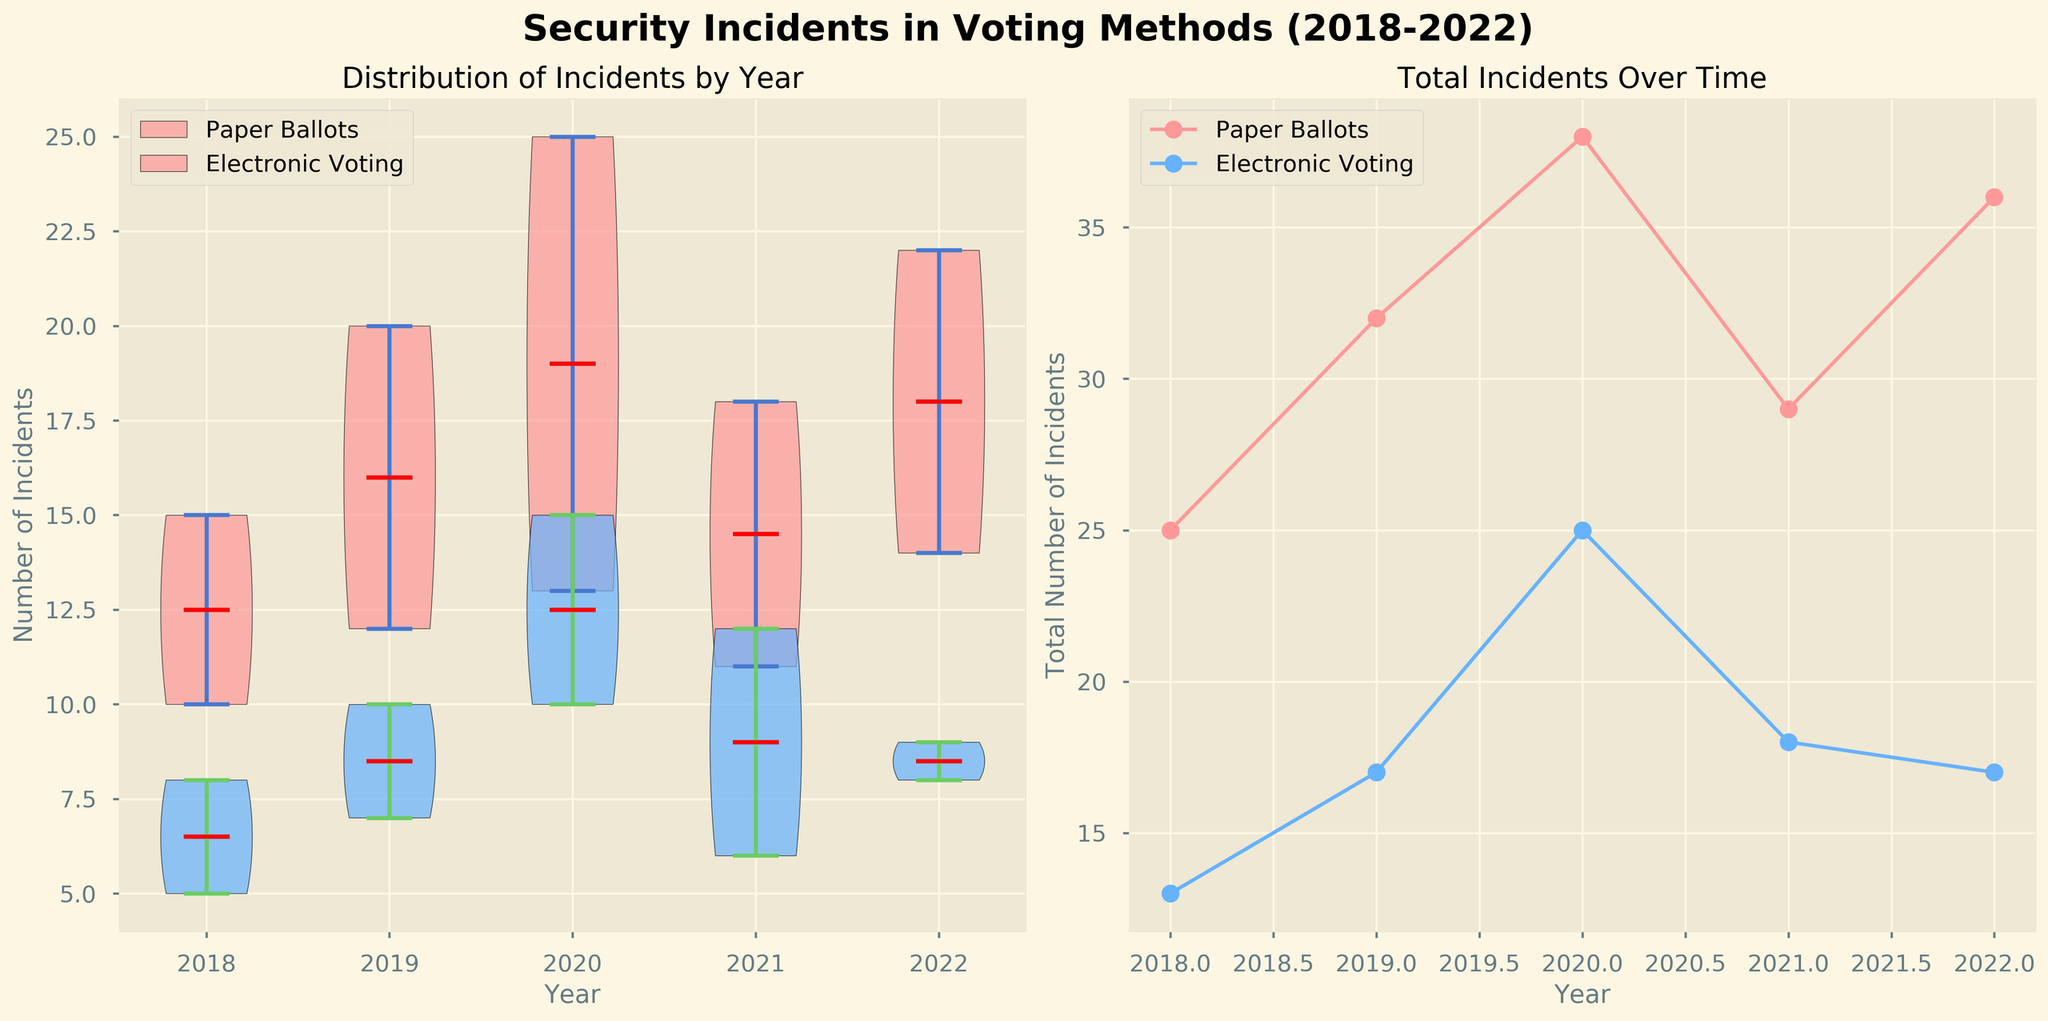What's the title of the figure? The title is usually displayed at the top of the figure, and it states the main topic or focus of the visualized data. In this case, it's clearly labeled at the top of the figure.
Answer: Security Incidents in Voting Methods (2018-2022) What are the unique voting methods shown in the figure? The unique voting methods are often shown in the legends or labels in a plot. Here, we see two distinct methods labeled in the legend and represented by different colors in the plots.
Answer: Paper Ballots and Electronic Voting Which year had the highest total number of security incidents across all methods? To find the highest total, sum the incidents for each year in both plots, then compare these sums. The year 2020 has the highest total when looking at both the line and violin plots.
Answer: 2020 What color represents 'Electronic Voting' in the plots? The colors associated with different methods can usually be deduced from the legend or the distinct colors used in the plot elements. The color for 'Electronic Voting' in this figure is visible in both the line and violin plots.
Answer: Blue Which method had a higher median number of incidents in 2020? The median is shown as a red line in the violin plot. Comparing the medians of 'Paper Ballots' and 'Electronic Voting' in 2020 within their respective violin plots will reveal this information.
Answer: Paper Ballots What is the general trend of security incidents for 'Paper Ballots' over the years in the figure? Observing the line plot for 'Paper Ballots' shows the general pattern or trend of incident counts over the years without delving into specifics.
Answer: Increasing In which year did 'Electronic Voting' have the fewest incidents? From the line plot for 'Electronic Voting', we can visually identify the lowest point over the years.
Answer: 2018 By how much did the total incidents for 'Electronic Voting' increase from 2018 to 2020? To calculate this, subtract the total incidents in 2018 from those in 2020, as shown in the line plot for 'Electronic Voting'. The total in 2020 is higher by (15 + 10 - (8 + 5)).
Answer: 12 Which method shows more variability in incident counts, as indicated by the width of the violins? The width of the violin plots reflects the variability in the data. Comparing the widths of the violins for both methods will indicate which has more variability.
Answer: Paper Ballots Is there any year where 'Paper Ballots' had fewer total incidents than 'Electronic Voting'? By comparing the sums of the incident types for 'Paper Ballots' and 'Electronic Voting' for each year using either subplot, we see no year where 'Paper Ballots' has fewer incidents.
Answer: No 